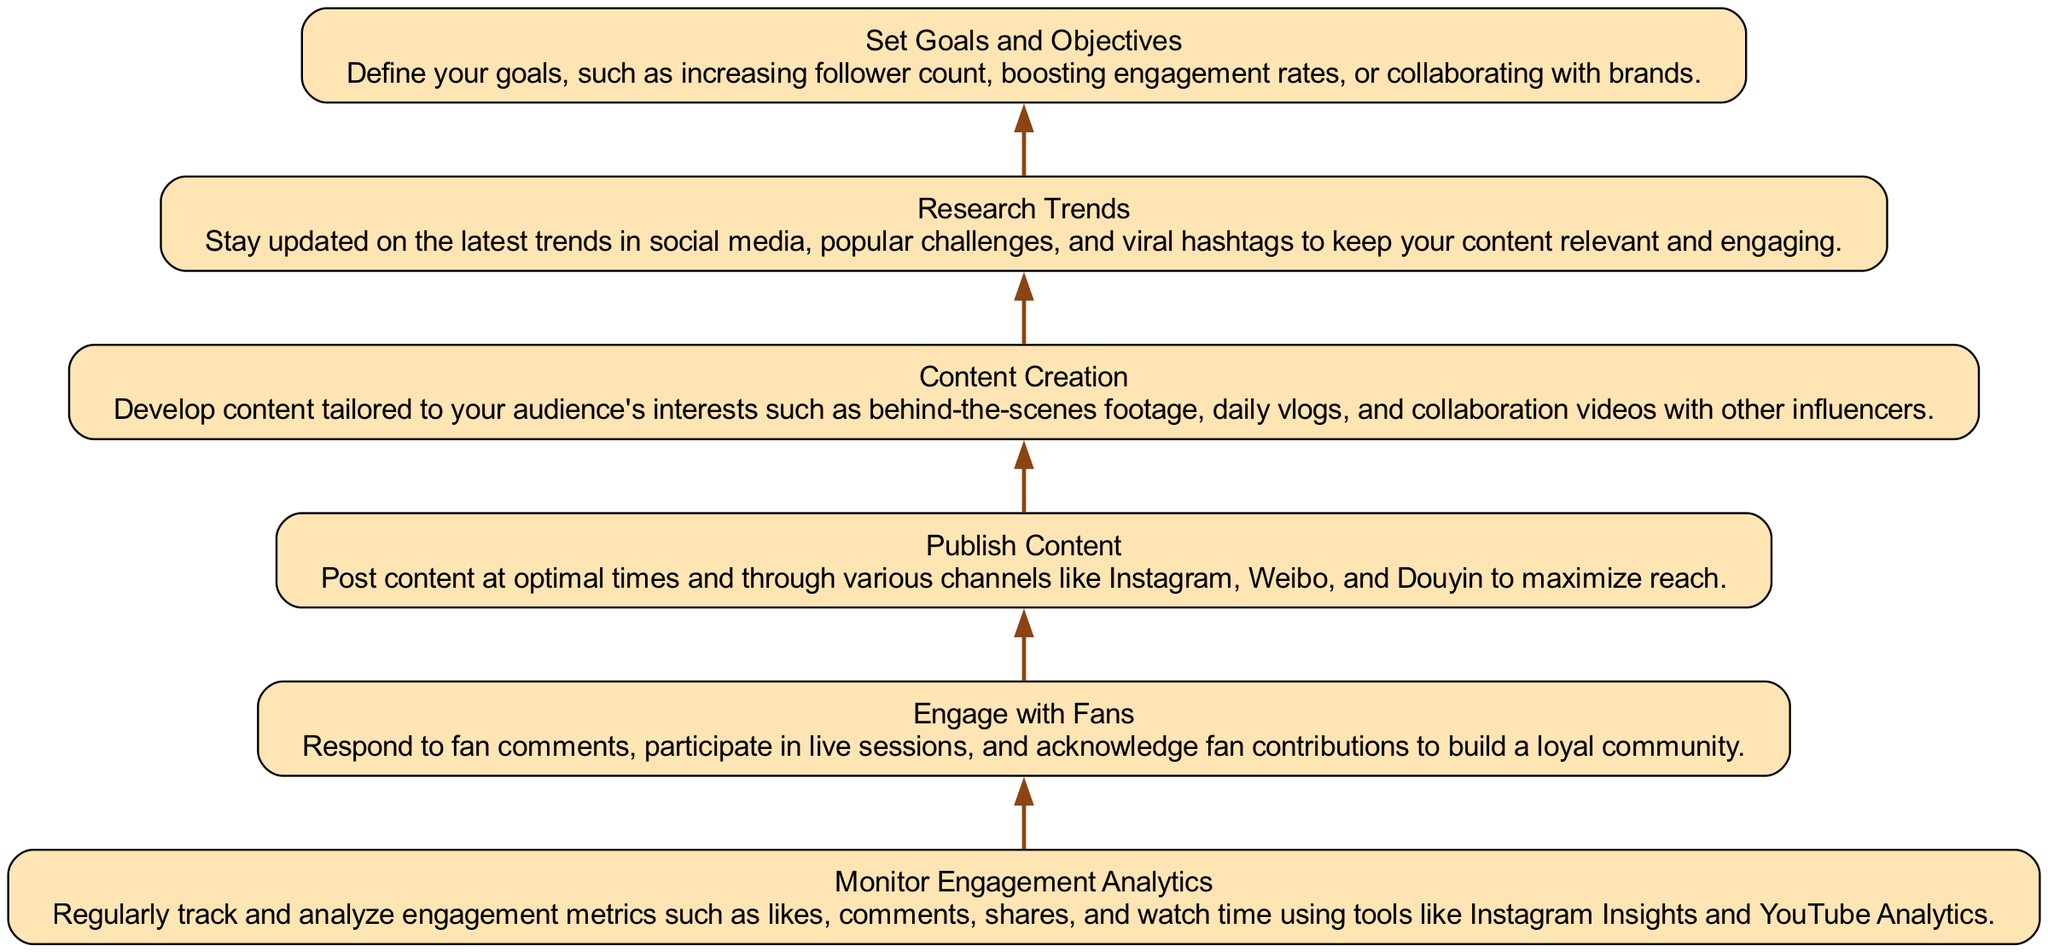What's the first step in the flow? The flow starts with "Set Goals and Objectives," which is at the bottom of the diagram. This node initiates the entire strategy by outlining the goals to achieve in social media content creation.
Answer: Set Goals and Objectives How many nodes are in the diagram? By counting the elements listed in the diagram, there are a total of six distinct nodes that represent the major steps in the content creation and engagement strategy.
Answer: Six What is the last action before "Monitor Engagement Analytics"? The node directly above "Monitor Engagement Analytics" is "Engage with Fans," which is the last step before monitoring engagement metrics in the flow.
Answer: Engage with Fans Which step focuses on understanding audience interests? The "Content Creation" node is dedicated to developing content that is tailored to the audience's interests, such as behind-the-scenes and collaboration videos.
Answer: Content Creation What is the relationship between "Research Trends" and "Publish Content"? "Research Trends" directly impacts "Publish Content" as understanding the latest trends and challenges is crucial for creating relevant posts that maximize reach. Therefore, "Research Trends" influences the timing and content of what gets published.
Answer: Influences What comes after "Publish Content" in the workflow? Following "Publish Content," the next step indicated by the flow in the diagram is "Monitor Engagement Analytics," reflecting the importance of tracking engagement after content is shared.
Answer: Monitor Engagement Analytics Which node emphasizes community building? The phase focused on community engagement and building loyalty among fans is encapsulated in "Engage with Fans," where interactions like responding to comments occur.
Answer: Engage with Fans What is the primary focus of the "Set Goals and Objectives" step? This step is about defining the ambitions such as increasing follower count or engagement rates, which serves as a foundation for the overall strategy.
Answer: Defining ambitions 